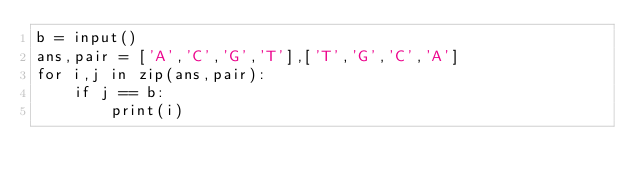Convert code to text. <code><loc_0><loc_0><loc_500><loc_500><_Python_>b = input()
ans,pair = ['A','C','G','T'],['T','G','C','A']
for i,j in zip(ans,pair):
    if j == b:
        print(i)</code> 